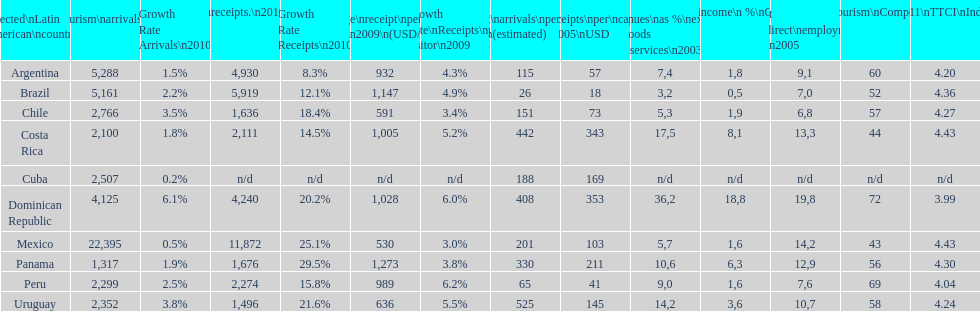Which nation had the greatest per capita receipts in 2005? Dominican Republic. 